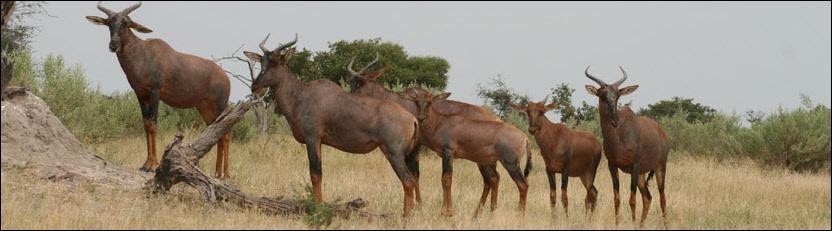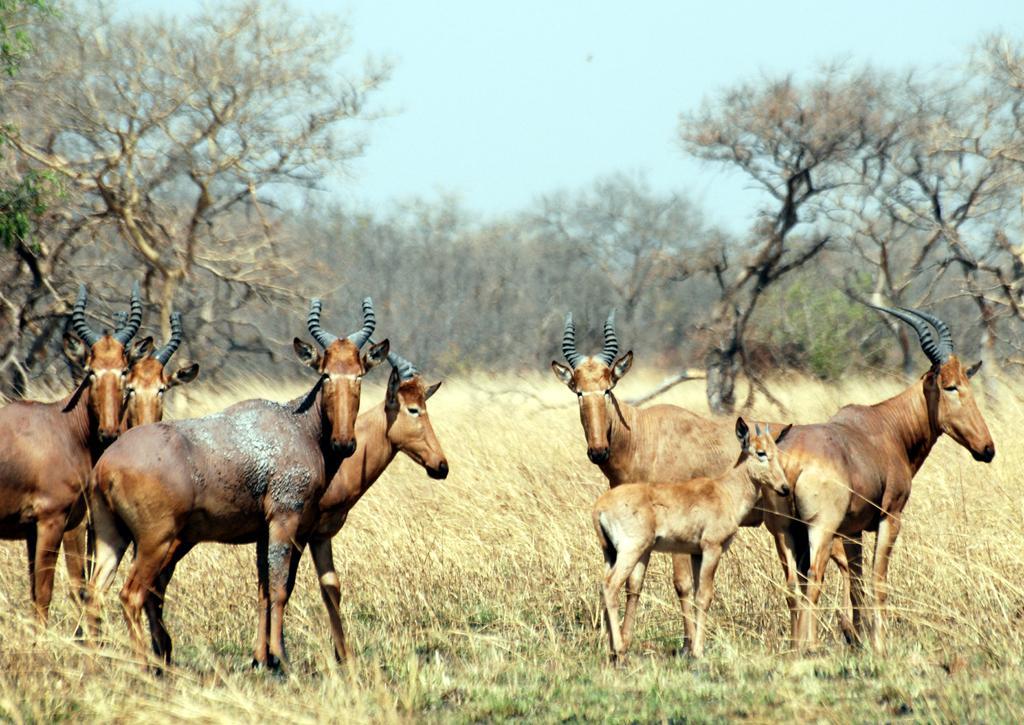The first image is the image on the left, the second image is the image on the right. For the images shown, is this caption "A young hooved animal without big horns stands facing right, in front of at least one big-horned animal." true? Answer yes or no. Yes. 